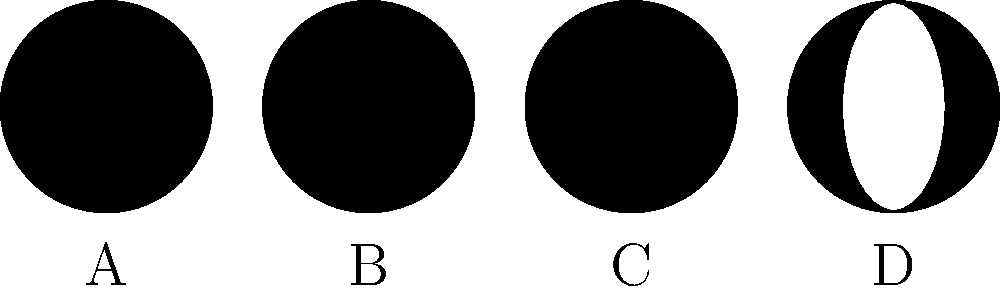Examine the series of moon phase diagrams labeled A through D. Which diagram represents the First Quarter Moon phase? Let's analyze each diagram step-by-step:

1. Diagram A: This shows a completely dark circle, representing the New Moon phase.

2. Diagram B: This shows a half-illuminated circle with the right side lit. This represents the First Quarter Moon phase.

3. Diagram C: This shows a fully illuminated circle, representing the Full Moon phase.

4. Diagram D: This shows a half-illuminated circle with the left side lit. This represents the Last Quarter Moon phase.

The First Quarter Moon occurs when the right half of the moon is illuminated from our perspective on Earth. This happens about a week after the New Moon, as the moon moves through its waxing phases.

In the First Quarter phase, the moon appears as a half-circle in the sky, with the right side illuminated. This is exactly what we see in diagram B.
Answer: B 